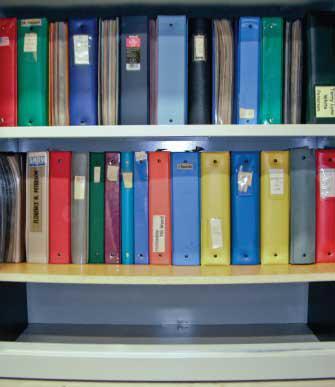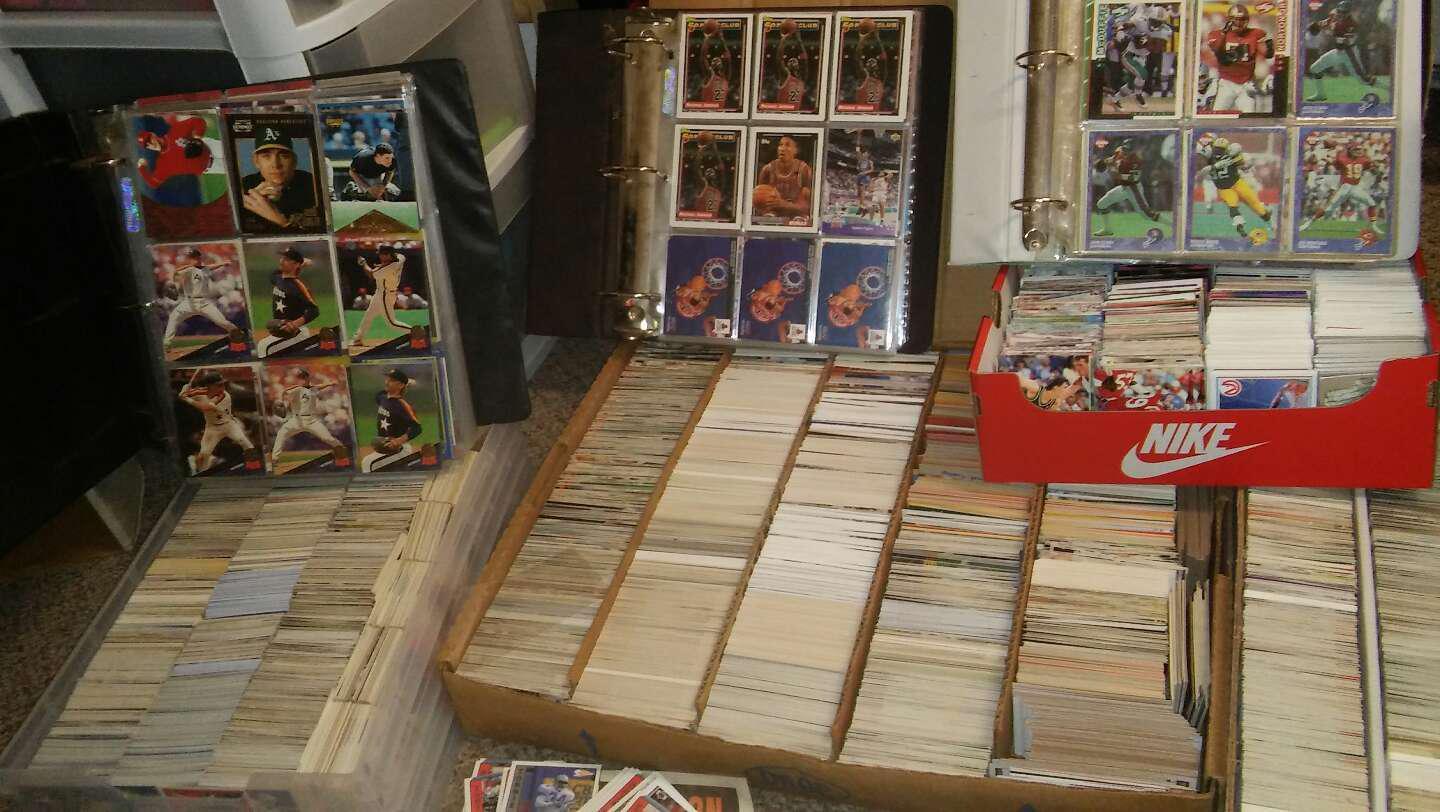The first image is the image on the left, the second image is the image on the right. Given the left and right images, does the statement "Collector cards arranged in plastic pockets of notebook pages are shown in one image." hold true? Answer yes or no. Yes. 